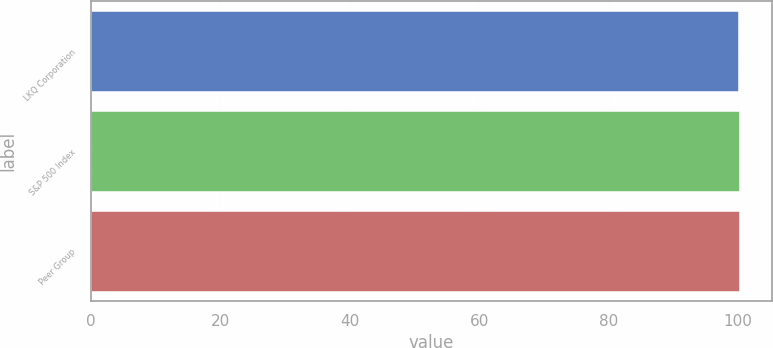Convert chart to OTSL. <chart><loc_0><loc_0><loc_500><loc_500><bar_chart><fcel>LKQ Corporation<fcel>S&P 500 Index<fcel>Peer Group<nl><fcel>100<fcel>100.1<fcel>100.2<nl></chart> 